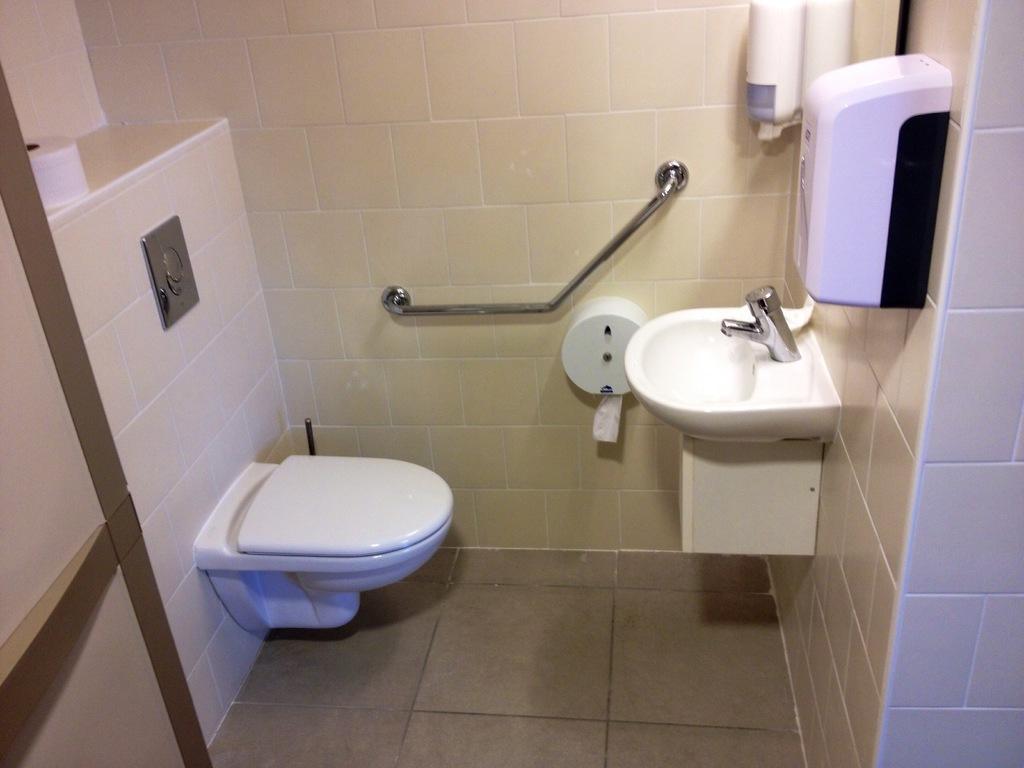Could you give a brief overview of what you see in this image? This picture is taken inside the room. In this image, on the left side, we can see a toilet and tissues. On the right side, we can see a wash basin, hand sanitizer. In the background, we can see a tissue roll and a metal rod. 